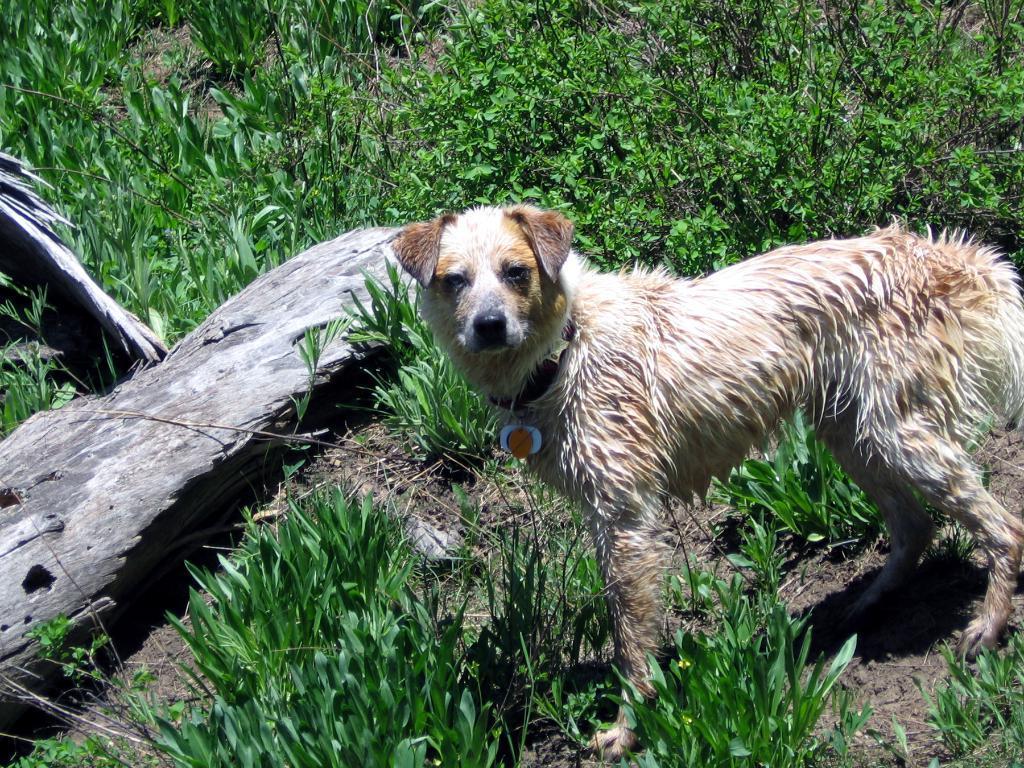How would you summarize this image in a sentence or two? This picture is clicked outside. In the foreground we can see the plants and a dog standing on the ground. In the background there are some objects lying on the ground and we can see the plants. 